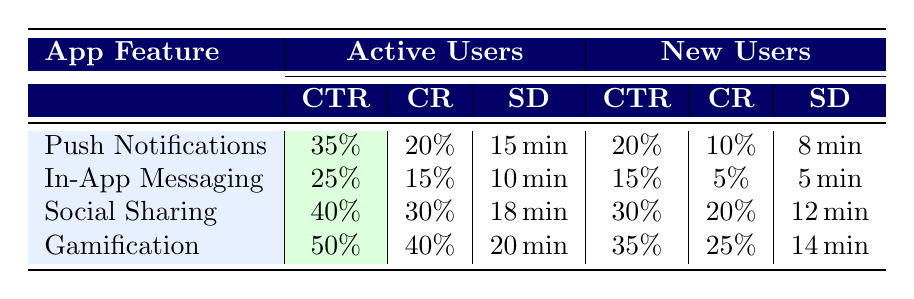What is the click-through rate for Gamification among Active Users? The table shows that the click-through rate (CTR) for Gamification under Active Users is 50%.
Answer: 50% Which app feature has the highest conversion rate among New Users? By comparing the conversion rates in the New Users column, Gamification has the highest rate at 25%.
Answer: Gamification What is the average session duration for Social Sharing across both user segments? For Active Users, the session duration is 18 minutes, and for New Users, it's 12 minutes. The average is (18 + 12) / 2 = 15 minutes.
Answer: 15 minutes Do Active Users have a higher session duration with Push Notifications than New Users? The session duration for Active Users with Push Notifications is 15 minutes, while for New Users, it is 8 minutes. Since 15 is greater than 8, the statement is true.
Answer: Yes What is the difference in click-through rates between In-App Messaging for Active Users and New Users? The click-through rate for Active Users is 25%, and for New Users, it is 15%. The difference is 25% - 15% = 10%.
Answer: 10% 